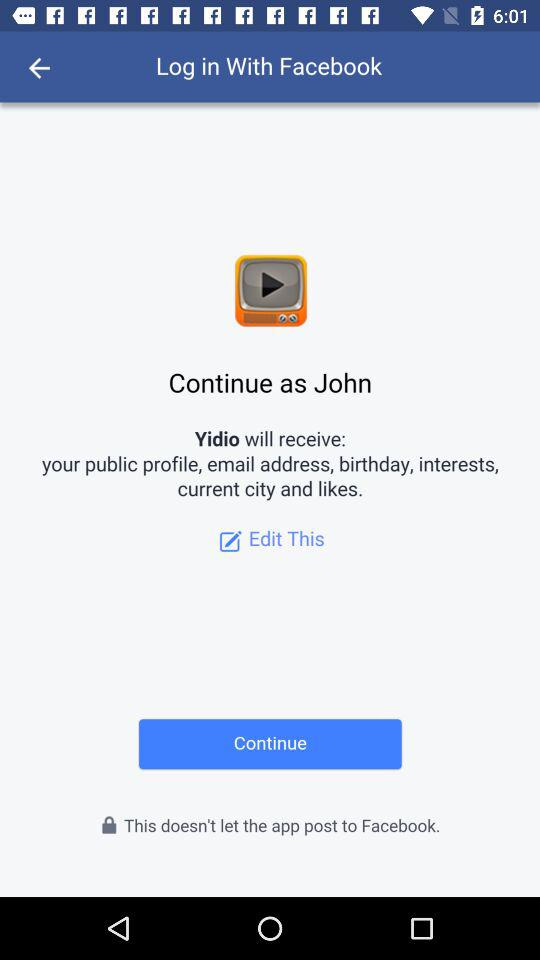What is the name of the user? The name of the user is John. 